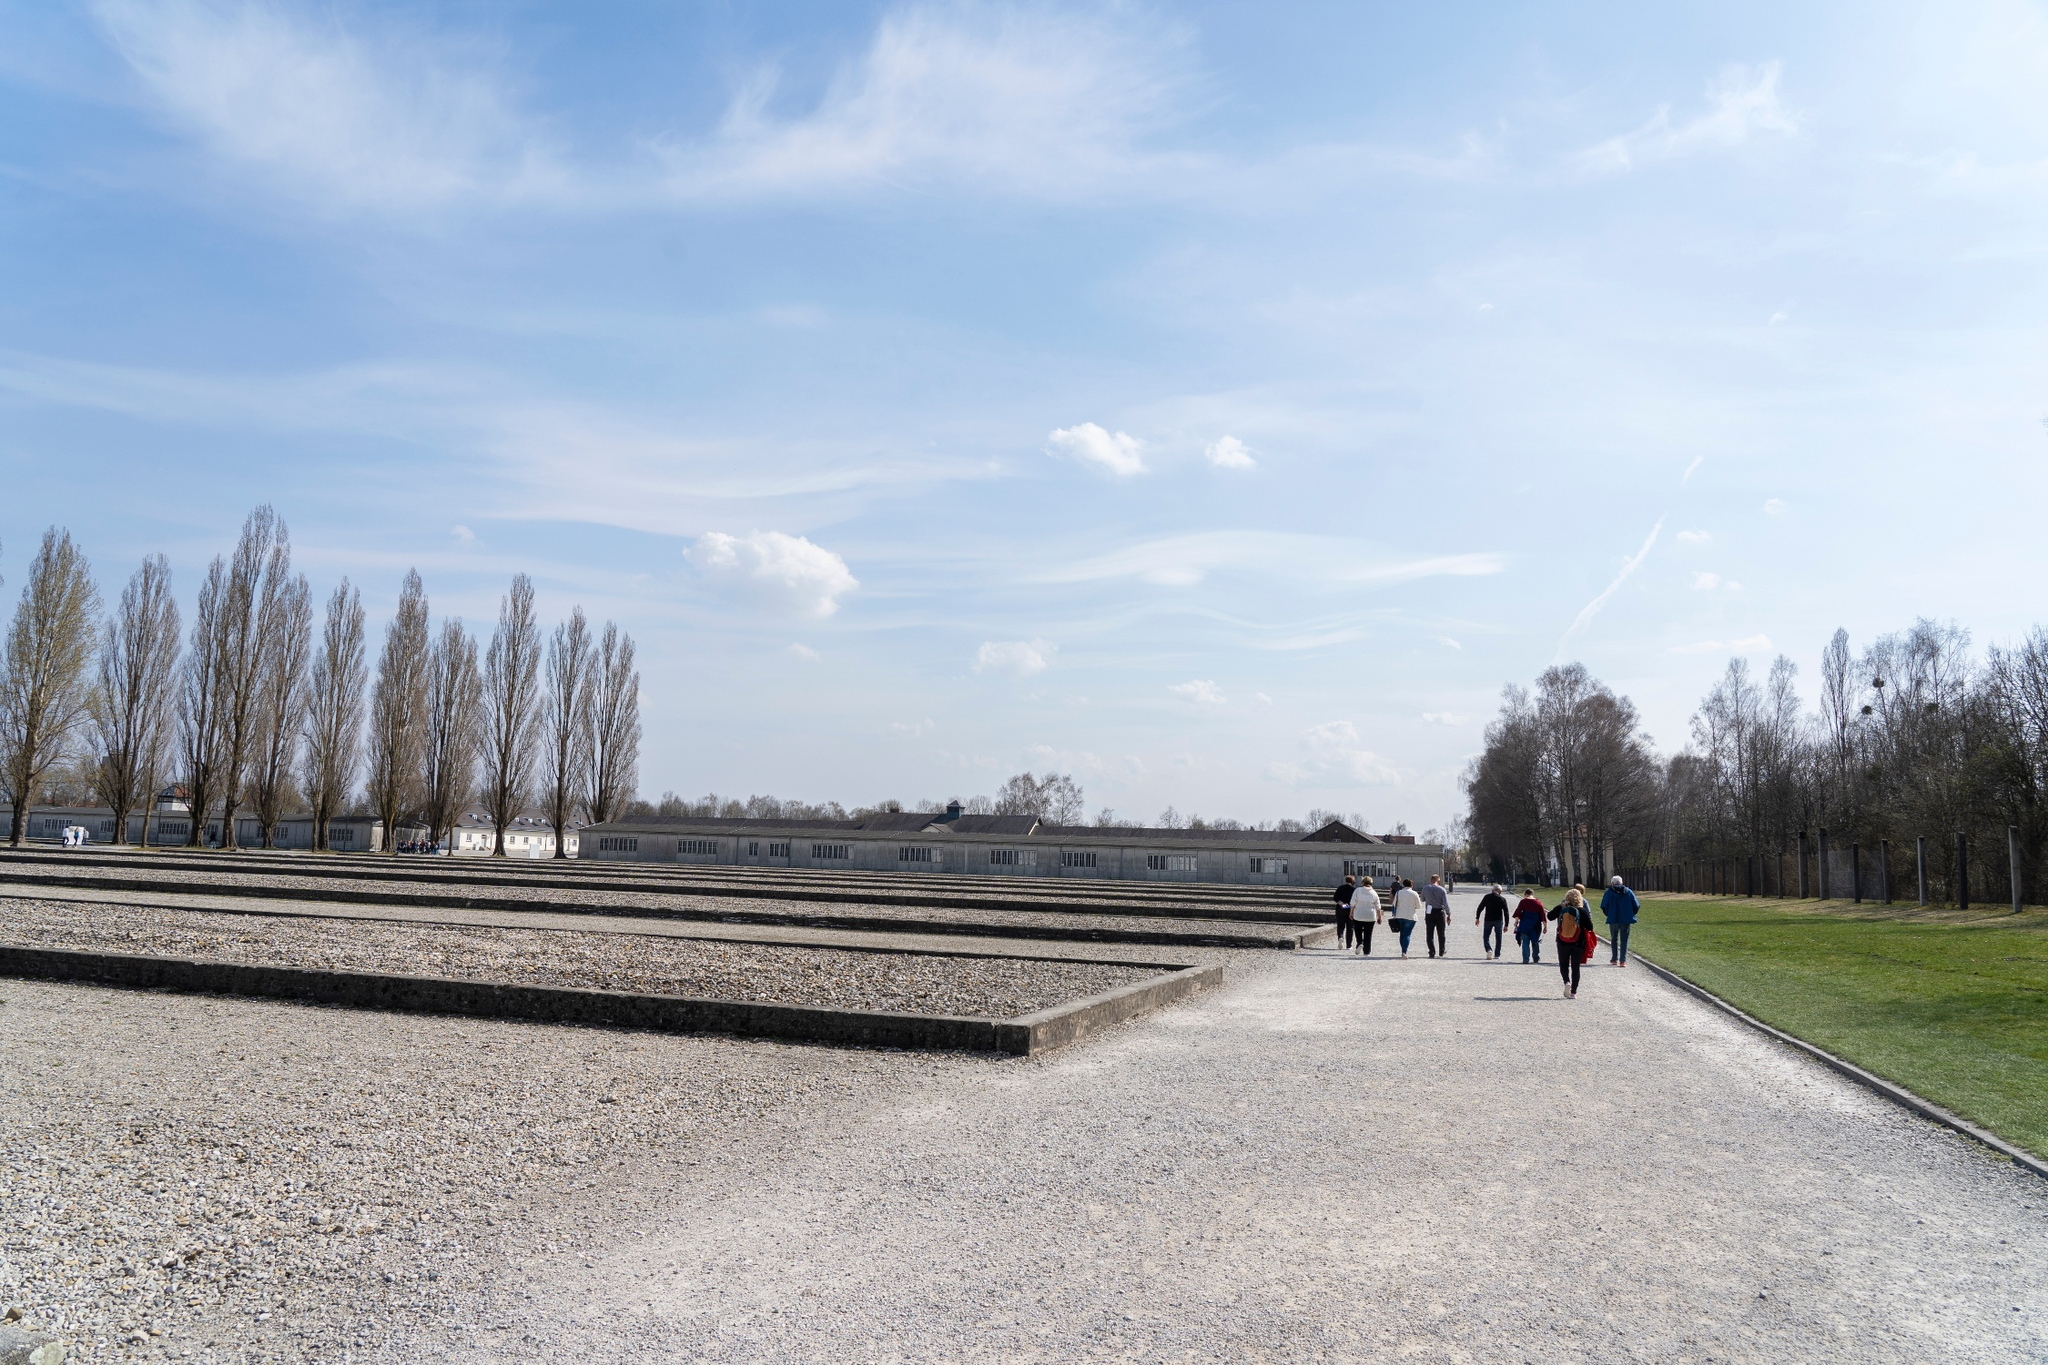Can you describe the main features of this image for me? The image depicts a scene at the Dachau Concentration Camp Memorial Site in Germany. From a low vantage point, the viewer's gaze follows a gravel path leading towards a notable structure in the distance. A small group of people appears in the middle of the path, possibly engaged in a historical exploration or paying respects. The backdrop features a prominent, linear concrete wall contrasted against an expansive blue sky adorned with a few scattered clouds. On the left, a series of tall, leafless trees align parallel to the path, marking the boundary of the site. The ground is primarily composed of gravel and sparse grass patches, hinting at early spring. Despite the remembrance of a somber history, the image is serene, highlighted by the clear, bright weather, and the surrounding greenery. 